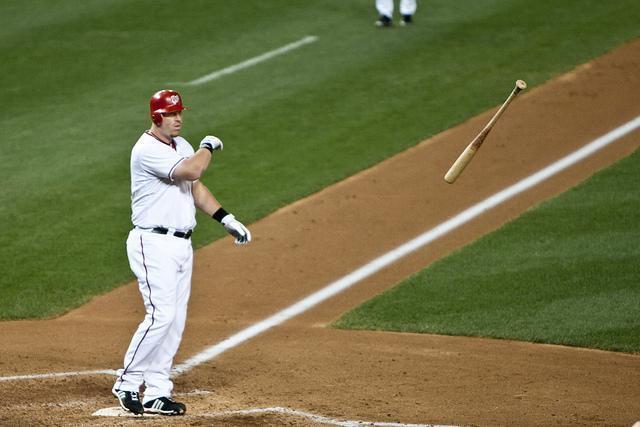How many players are there?
Give a very brief answer. 1. How many dogs are there?
Give a very brief answer. 0. 